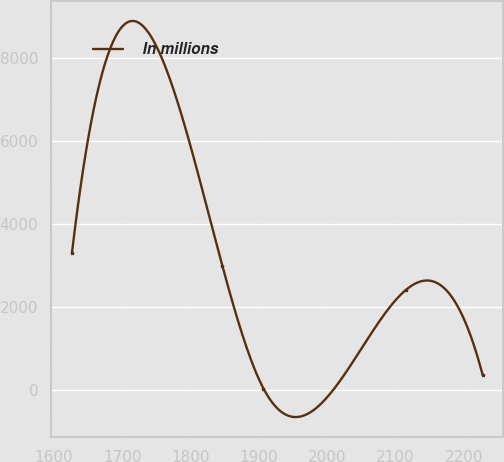<chart> <loc_0><loc_0><loc_500><loc_500><line_chart><ecel><fcel>In millions<nl><fcel>1626.62<fcel>3302.91<nl><fcel>1846.67<fcel>2987.14<nl><fcel>1906.76<fcel>33.2<nl><fcel>2114.73<fcel>2404.68<nl><fcel>2227.56<fcel>348.97<nl></chart> 